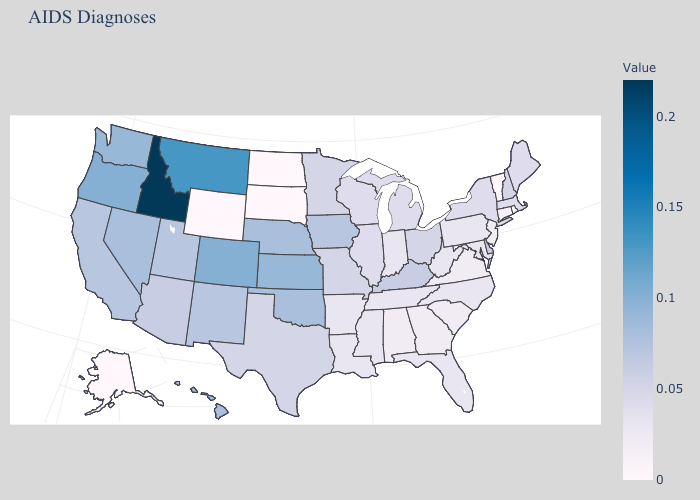Among the states that border Nebraska , does Colorado have the lowest value?
Answer briefly. No. Does Florida have a higher value than South Dakota?
Answer briefly. Yes. Which states hav the highest value in the West?
Keep it brief. Idaho. Does Indiana have the highest value in the MidWest?
Give a very brief answer. No. Does South Dakota have the lowest value in the MidWest?
Answer briefly. Yes. Is the legend a continuous bar?
Be succinct. Yes. 